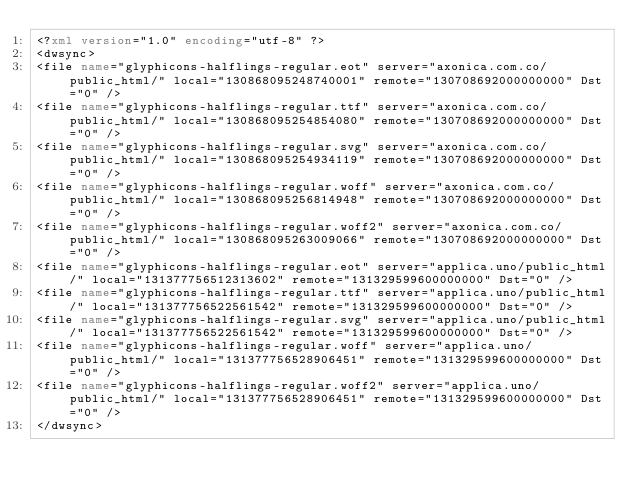Convert code to text. <code><loc_0><loc_0><loc_500><loc_500><_XML_><?xml version="1.0" encoding="utf-8" ?>
<dwsync>
<file name="glyphicons-halflings-regular.eot" server="axonica.com.co/public_html/" local="130868095248740001" remote="130708692000000000" Dst="0" />
<file name="glyphicons-halflings-regular.ttf" server="axonica.com.co/public_html/" local="130868095254854080" remote="130708692000000000" Dst="0" />
<file name="glyphicons-halflings-regular.svg" server="axonica.com.co/public_html/" local="130868095254934119" remote="130708692000000000" Dst="0" />
<file name="glyphicons-halflings-regular.woff" server="axonica.com.co/public_html/" local="130868095256814948" remote="130708692000000000" Dst="0" />
<file name="glyphicons-halflings-regular.woff2" server="axonica.com.co/public_html/" local="130868095263009066" remote="130708692000000000" Dst="0" />
<file name="glyphicons-halflings-regular.eot" server="applica.uno/public_html/" local="131377756512313602" remote="131329599600000000" Dst="0" />
<file name="glyphicons-halflings-regular.ttf" server="applica.uno/public_html/" local="131377756522561542" remote="131329599600000000" Dst="0" />
<file name="glyphicons-halflings-regular.svg" server="applica.uno/public_html/" local="131377756522561542" remote="131329599600000000" Dst="0" />
<file name="glyphicons-halflings-regular.woff" server="applica.uno/public_html/" local="131377756528906451" remote="131329599600000000" Dst="0" />
<file name="glyphicons-halflings-regular.woff2" server="applica.uno/public_html/" local="131377756528906451" remote="131329599600000000" Dst="0" />
</dwsync></code> 